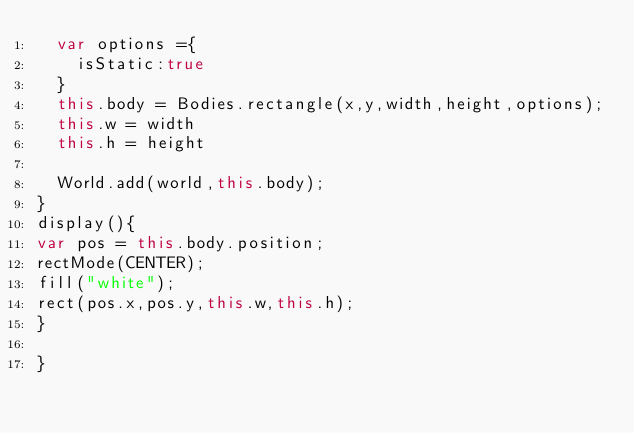<code> <loc_0><loc_0><loc_500><loc_500><_JavaScript_>  var options ={
    isStatic:true
  }
  this.body = Bodies.rectangle(x,y,width,height,options);
  this.w = width
  this.h = height

  World.add(world,this.body);
}
display(){
var pos = this.body.position;
rectMode(CENTER);
fill("white");
rect(pos.x,pos.y,this.w,this.h);
}

}</code> 